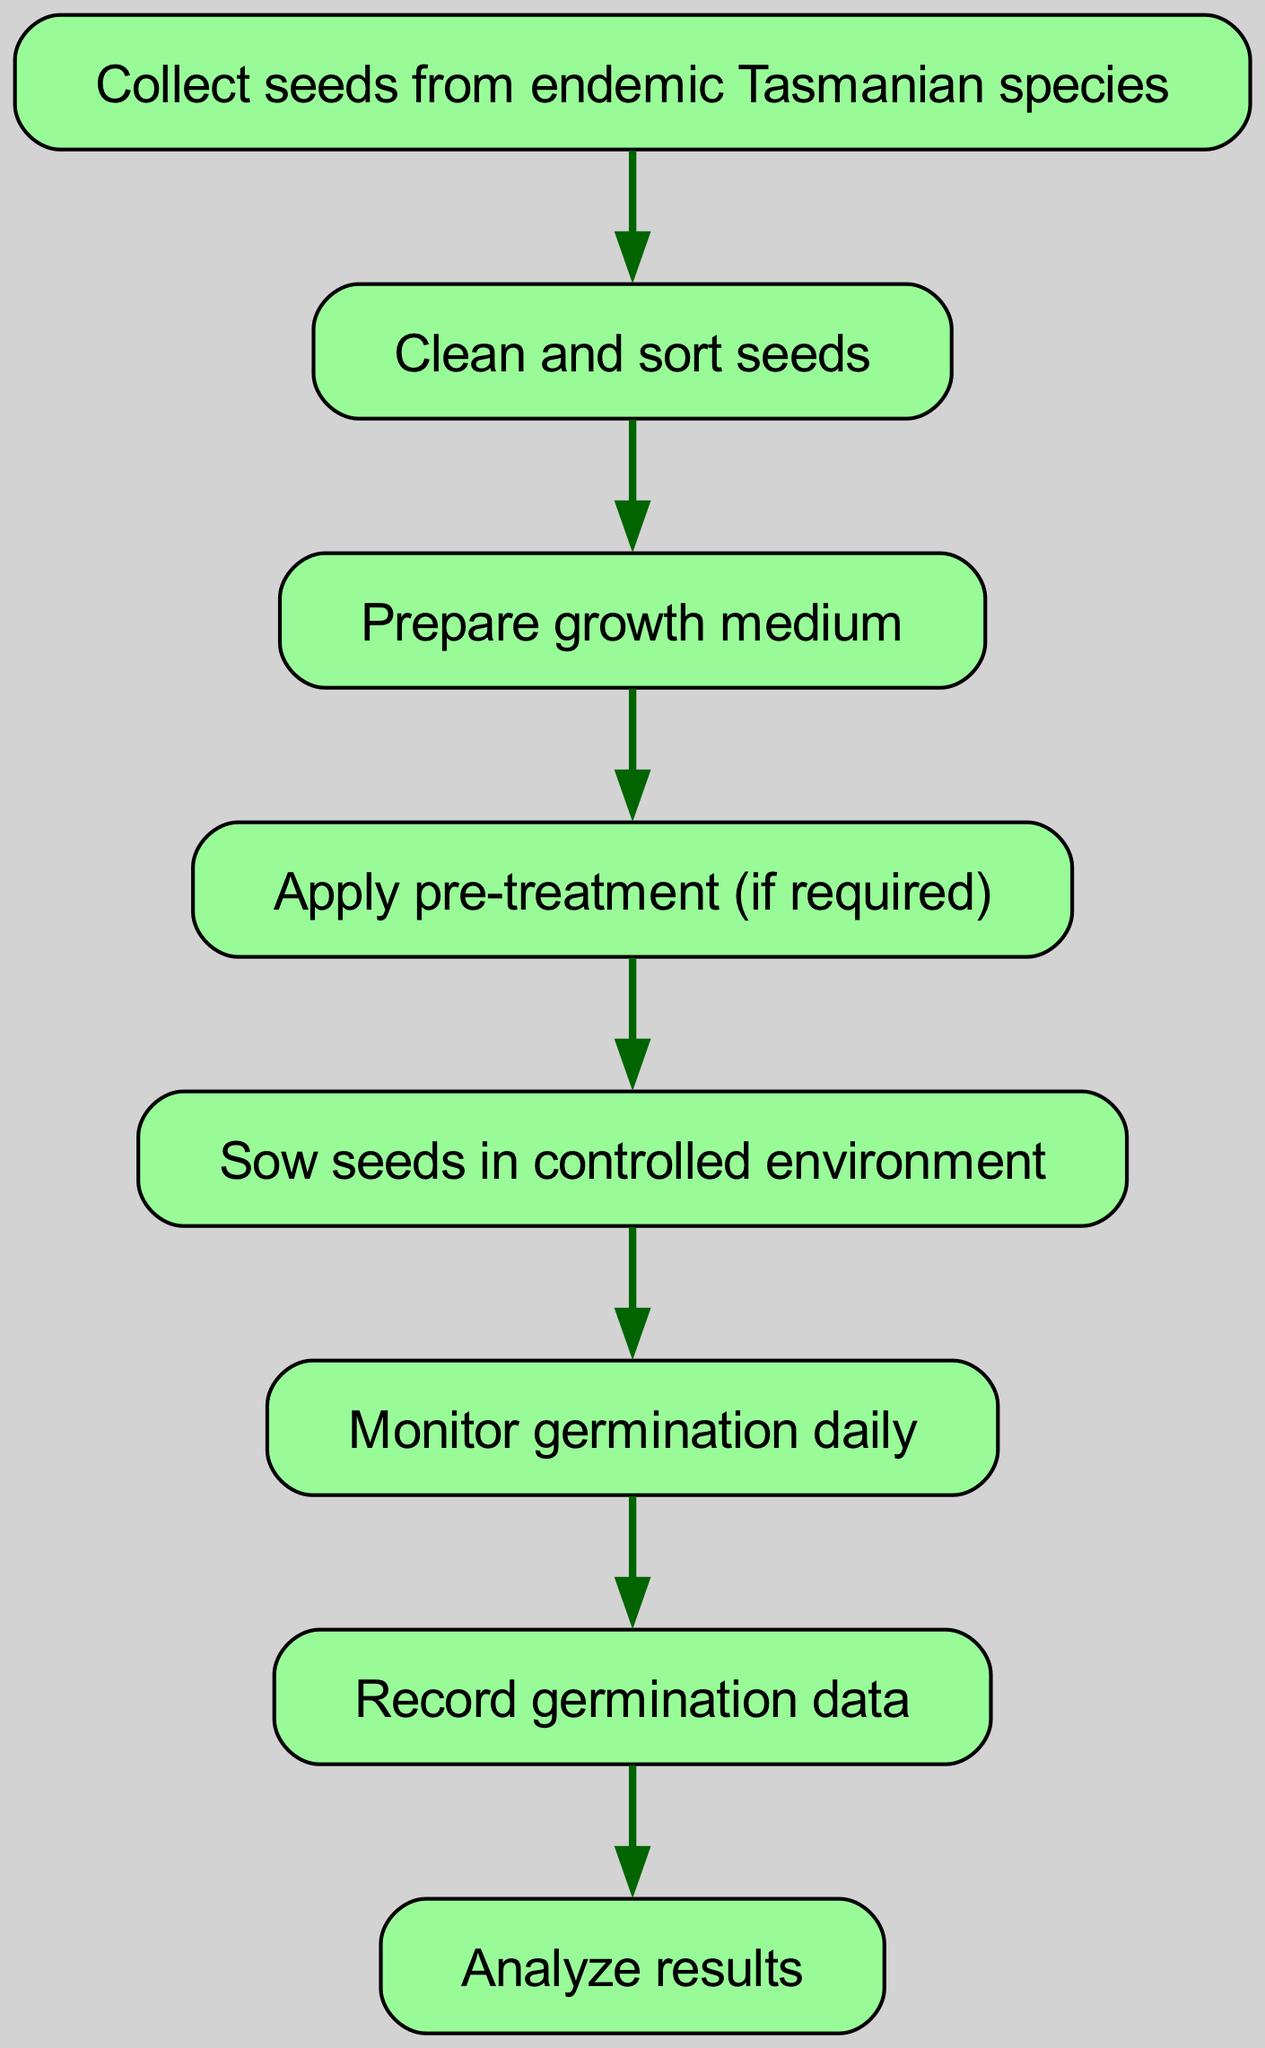What is the first step of the workflow? The first node in the diagram is labeled "Collect seeds from endemic Tasmanian species," which indicates that this is the initial action to be completed in the workflow.
Answer: Collect seeds from endemic Tasmanian species How many total nodes are in the diagram? By counting the nodes from the data provided, there are a total of 8 nodes, each representing a distinct step in the seed germination experiment workflow.
Answer: 8 What node follows the "Prepare growth medium" step? The "Prepare growth medium" step, which is the third node in the workflow, is followed by the "Apply pre-treatment (if required)" step, as indicated by the directed edge in the diagram.
Answer: Apply pre-treatment (if required) Which steps involve monitoring or recording? The steps that involve monitoring or recording are "Monitor germination daily" and "Record germination data." The diagram shows a direct connection from monitoring to recording, illustrating the flow of data processing in the experiment.
Answer: Monitor germination daily, Record germination data What is the last step of the workflow? The last node in the flowchart is labeled "Analyze results." This indicates that after all previous steps have been completed, the final step involves analyzing the data acquired from the germination experiment.
Answer: Analyze results Which steps are dependent on the "Clean and sort seeds" step? The "Clean and sort seeds" step is followed by "Prepare growth medium," making it a prerequisite for that node. Thus, "Prepare growth medium" is dependent on the completion of the "Clean and sort seeds" step.
Answer: Prepare growth medium How many edges are there in the diagram? By examining the provided edges, there are a total of 7 edges that connect the 8 nodes in the workflow, which represent the distinct transitions between each activity.
Answer: 7 What is the relationship between "Sow seeds in controlled environment" and "Monitor germination daily"? The relationship, as shown by the directed edge, indicates that "Sow seeds in controlled environment" is the action that must be completed before proceeding to "Monitor germination daily," establishing a sequential workflow.
Answer: Sow seeds in controlled environment → Monitor germination daily 